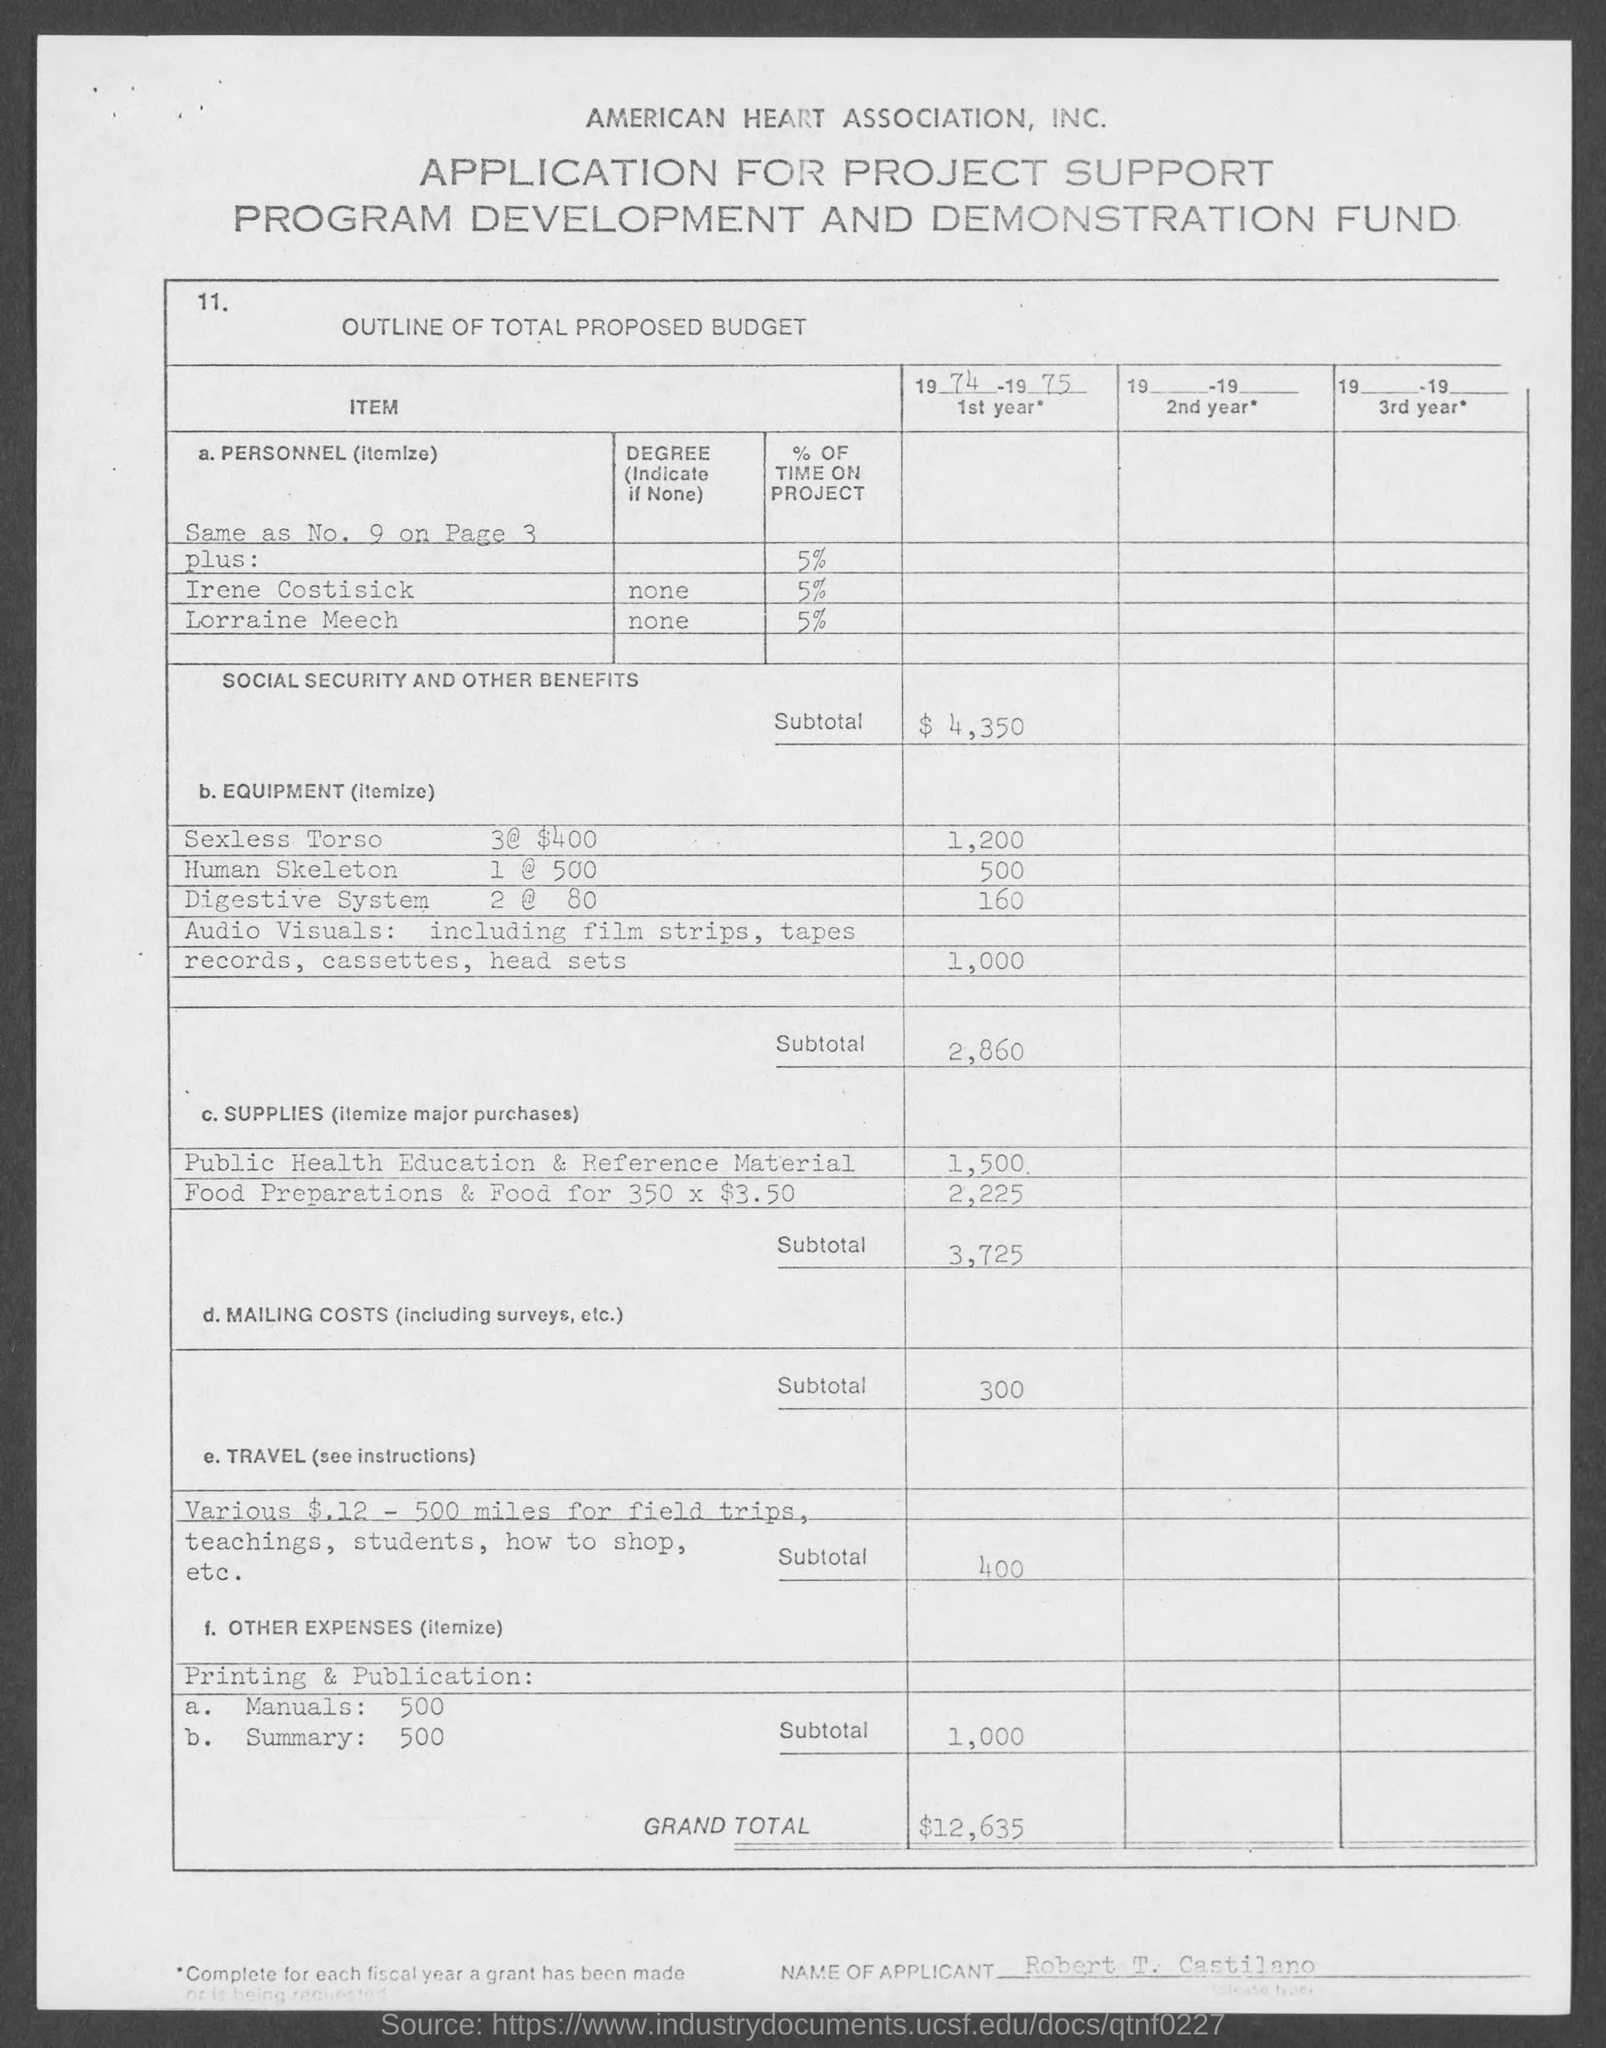Highlight a few significant elements in this photo. The subtotal for travel is 400. The budget for Digestive System 2 @ 80 is 160. The name of the applicant is Robert T. Castilano. The subtotal for social security and other benefits for the years 1974 and 1975 was $4,350. The subtotal for equipment is 2,860. 